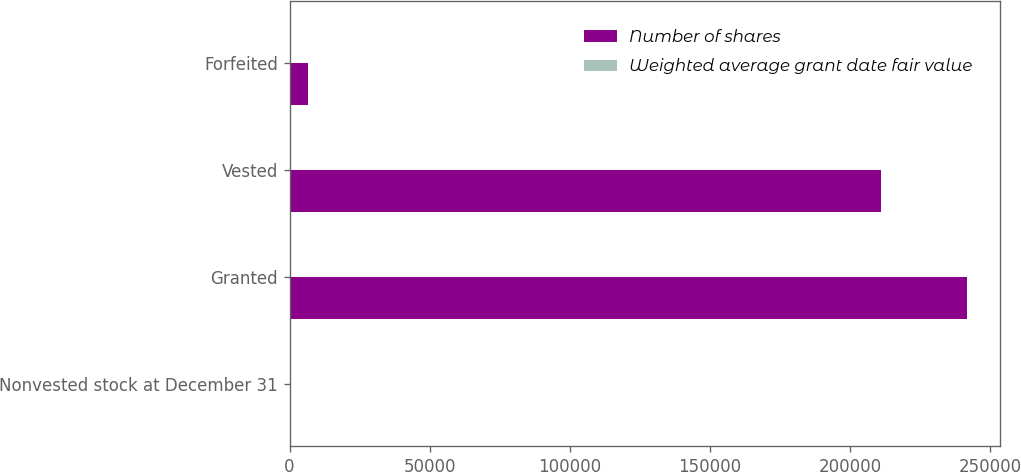<chart> <loc_0><loc_0><loc_500><loc_500><stacked_bar_chart><ecel><fcel>Nonvested stock at December 31<fcel>Granted<fcel>Vested<fcel>Forfeited<nl><fcel>Number of shares<fcel>77.19<fcel>241681<fcel>211235<fcel>6421<nl><fcel>Weighted average grant date fair value<fcel>77.19<fcel>64.1<fcel>48.14<fcel>64.5<nl></chart> 